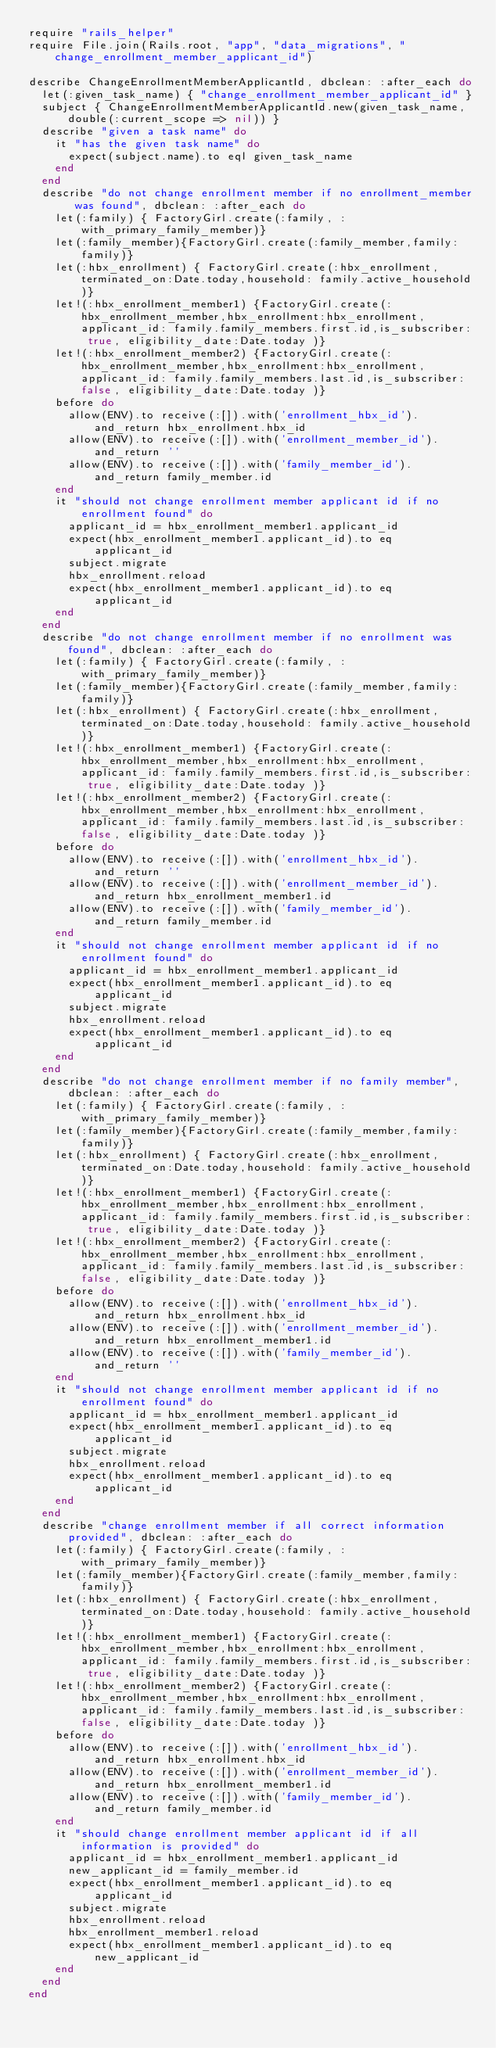<code> <loc_0><loc_0><loc_500><loc_500><_Ruby_>require "rails_helper"
require File.join(Rails.root, "app", "data_migrations", "change_enrollment_member_applicant_id")

describe ChangeEnrollmentMemberApplicantId, dbclean: :after_each do
  let(:given_task_name) { "change_enrollment_member_applicant_id" }
  subject { ChangeEnrollmentMemberApplicantId.new(given_task_name, double(:current_scope => nil)) }
  describe "given a task name" do
    it "has the given task name" do
      expect(subject.name).to eql given_task_name
    end
  end
  describe "do not change enrollment member if no enrollment_member was found", dbclean: :after_each do
    let(:family) { FactoryGirl.create(:family, :with_primary_family_member)}
    let(:family_member){FactoryGirl.create(:family_member,family:family)}
    let(:hbx_enrollment) { FactoryGirl.create(:hbx_enrollment,terminated_on:Date.today,household: family.active_household)}
    let!(:hbx_enrollment_member1) {FactoryGirl.create(:hbx_enrollment_member,hbx_enrollment:hbx_enrollment,applicant_id: family.family_members.first.id,is_subscriber: true, eligibility_date:Date.today )}
    let!(:hbx_enrollment_member2) {FactoryGirl.create(:hbx_enrollment_member,hbx_enrollment:hbx_enrollment,applicant_id: family.family_members.last.id,is_subscriber: false, eligibility_date:Date.today )}
    before do
      allow(ENV).to receive(:[]).with('enrollment_hbx_id').and_return hbx_enrollment.hbx_id
      allow(ENV).to receive(:[]).with('enrollment_member_id').and_return ''
      allow(ENV).to receive(:[]).with('family_member_id').and_return family_member.id
    end
    it "should not change enrollment member applicant id if no enrollment found" do
      applicant_id = hbx_enrollment_member1.applicant_id
      expect(hbx_enrollment_member1.applicant_id).to eq applicant_id
      subject.migrate
      hbx_enrollment.reload
      expect(hbx_enrollment_member1.applicant_id).to eq applicant_id
    end
  end
  describe "do not change enrollment member if no enrollment was found", dbclean: :after_each do
    let(:family) { FactoryGirl.create(:family, :with_primary_family_member)}
    let(:family_member){FactoryGirl.create(:family_member,family:family)}
    let(:hbx_enrollment) { FactoryGirl.create(:hbx_enrollment,terminated_on:Date.today,household: family.active_household)}
    let!(:hbx_enrollment_member1) {FactoryGirl.create(:hbx_enrollment_member,hbx_enrollment:hbx_enrollment,applicant_id: family.family_members.first.id,is_subscriber: true, eligibility_date:Date.today )}
    let!(:hbx_enrollment_member2) {FactoryGirl.create(:hbx_enrollment_member,hbx_enrollment:hbx_enrollment,applicant_id: family.family_members.last.id,is_subscriber: false, eligibility_date:Date.today )}
    before do
      allow(ENV).to receive(:[]).with('enrollment_hbx_id').and_return ''
      allow(ENV).to receive(:[]).with('enrollment_member_id').and_return hbx_enrollment_member1.id
      allow(ENV).to receive(:[]).with('family_member_id').and_return family_member.id
    end
    it "should not change enrollment member applicant id if no enrollment found" do
      applicant_id = hbx_enrollment_member1.applicant_id
      expect(hbx_enrollment_member1.applicant_id).to eq applicant_id
      subject.migrate
      hbx_enrollment.reload
      expect(hbx_enrollment_member1.applicant_id).to eq applicant_id
    end
  end
  describe "do not change enrollment member if no family member", dbclean: :after_each do
    let(:family) { FactoryGirl.create(:family, :with_primary_family_member)}
    let(:family_member){FactoryGirl.create(:family_member,family:family)}
    let(:hbx_enrollment) { FactoryGirl.create(:hbx_enrollment,terminated_on:Date.today,household: family.active_household)}
    let!(:hbx_enrollment_member1) {FactoryGirl.create(:hbx_enrollment_member,hbx_enrollment:hbx_enrollment,applicant_id: family.family_members.first.id,is_subscriber: true, eligibility_date:Date.today )}
    let!(:hbx_enrollment_member2) {FactoryGirl.create(:hbx_enrollment_member,hbx_enrollment:hbx_enrollment,applicant_id: family.family_members.last.id,is_subscriber: false, eligibility_date:Date.today )}
    before do
      allow(ENV).to receive(:[]).with('enrollment_hbx_id').and_return hbx_enrollment.hbx_id
      allow(ENV).to receive(:[]).with('enrollment_member_id').and_return hbx_enrollment_member1.id
      allow(ENV).to receive(:[]).with('family_member_id').and_return ''
    end
    it "should not change enrollment member applicant id if no enrollment found" do
      applicant_id = hbx_enrollment_member1.applicant_id
      expect(hbx_enrollment_member1.applicant_id).to eq applicant_id
      subject.migrate
      hbx_enrollment.reload
      expect(hbx_enrollment_member1.applicant_id).to eq applicant_id
    end
  end
  describe "change enrollment member if all correct information provided", dbclean: :after_each do
    let(:family) { FactoryGirl.create(:family, :with_primary_family_member)}
    let(:family_member){FactoryGirl.create(:family_member,family:family)}
    let(:hbx_enrollment) { FactoryGirl.create(:hbx_enrollment,terminated_on:Date.today,household: family.active_household)}
    let!(:hbx_enrollment_member1) {FactoryGirl.create(:hbx_enrollment_member,hbx_enrollment:hbx_enrollment,applicant_id: family.family_members.first.id,is_subscriber: true, eligibility_date:Date.today )}
    let!(:hbx_enrollment_member2) {FactoryGirl.create(:hbx_enrollment_member,hbx_enrollment:hbx_enrollment,applicant_id: family.family_members.last.id,is_subscriber: false, eligibility_date:Date.today )}
    before do
      allow(ENV).to receive(:[]).with('enrollment_hbx_id').and_return hbx_enrollment.hbx_id
      allow(ENV).to receive(:[]).with('enrollment_member_id').and_return hbx_enrollment_member1.id
      allow(ENV).to receive(:[]).with('family_member_id').and_return family_member.id
    end
    it "should change enrollment member applicant id if all information is provided" do
      applicant_id = hbx_enrollment_member1.applicant_id
      new_applicant_id = family_member.id
      expect(hbx_enrollment_member1.applicant_id).to eq applicant_id
      subject.migrate
      hbx_enrollment.reload
      hbx_enrollment_member1.reload
      expect(hbx_enrollment_member1.applicant_id).to eq new_applicant_id
    end
  end
end
</code> 